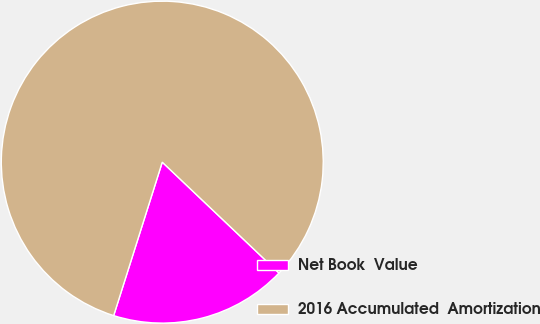<chart> <loc_0><loc_0><loc_500><loc_500><pie_chart><fcel>Net Book  Value<fcel>2016 Accumulated  Amortization<nl><fcel>17.79%<fcel>82.21%<nl></chart> 